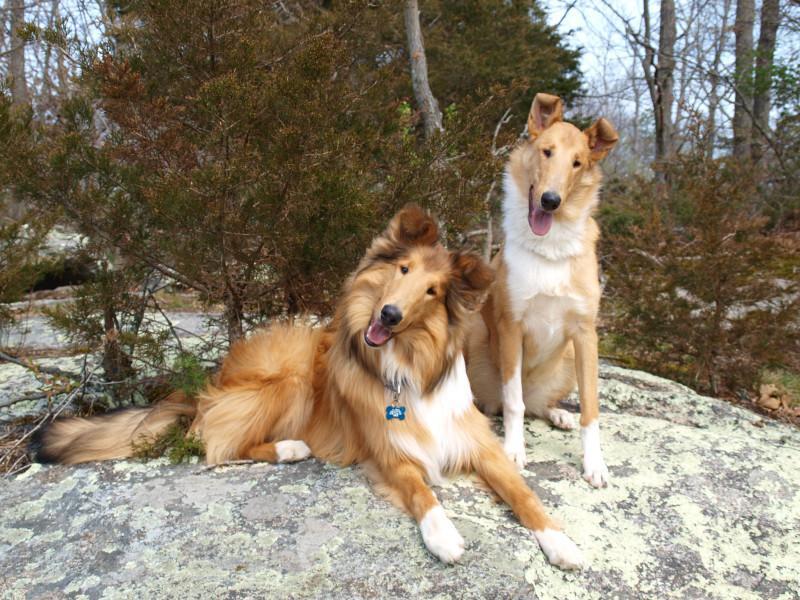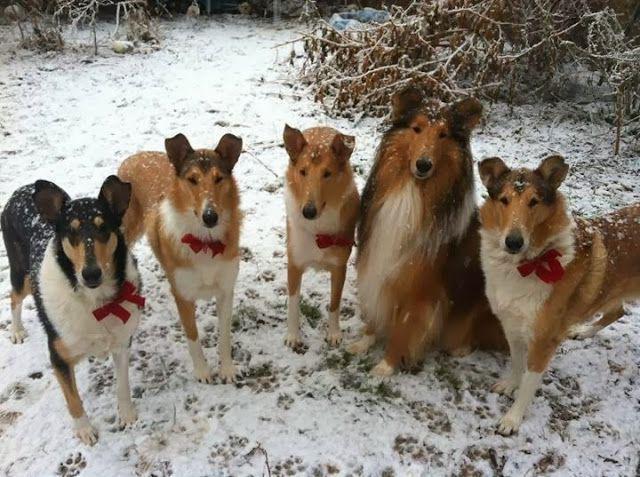The first image is the image on the left, the second image is the image on the right. Given the left and right images, does the statement "There are at most five dogs." hold true? Answer yes or no. No. The first image is the image on the left, the second image is the image on the right. Evaluate the accuracy of this statement regarding the images: "Two Collies beside each other have their heads cocked to the right.". Is it true? Answer yes or no. Yes. 